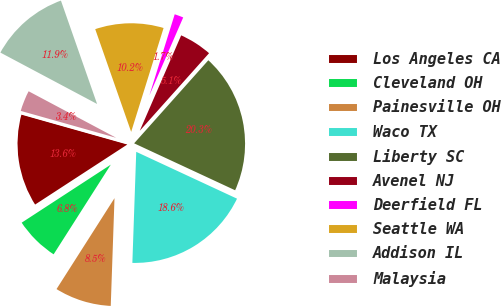Convert chart. <chart><loc_0><loc_0><loc_500><loc_500><pie_chart><fcel>Los Angeles CA<fcel>Cleveland OH<fcel>Painesville OH<fcel>Waco TX<fcel>Liberty SC<fcel>Avenel NJ<fcel>Deerfield FL<fcel>Seattle WA<fcel>Addison IL<fcel>Malaysia<nl><fcel>13.56%<fcel>6.78%<fcel>8.48%<fcel>18.63%<fcel>20.32%<fcel>5.09%<fcel>1.7%<fcel>10.17%<fcel>11.87%<fcel>3.4%<nl></chart> 